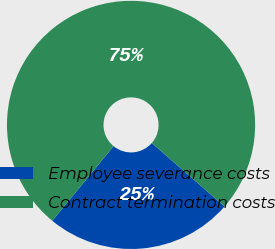Convert chart to OTSL. <chart><loc_0><loc_0><loc_500><loc_500><pie_chart><fcel>Employee severance costs<fcel>Contract termination costs<nl><fcel>24.53%<fcel>75.47%<nl></chart> 